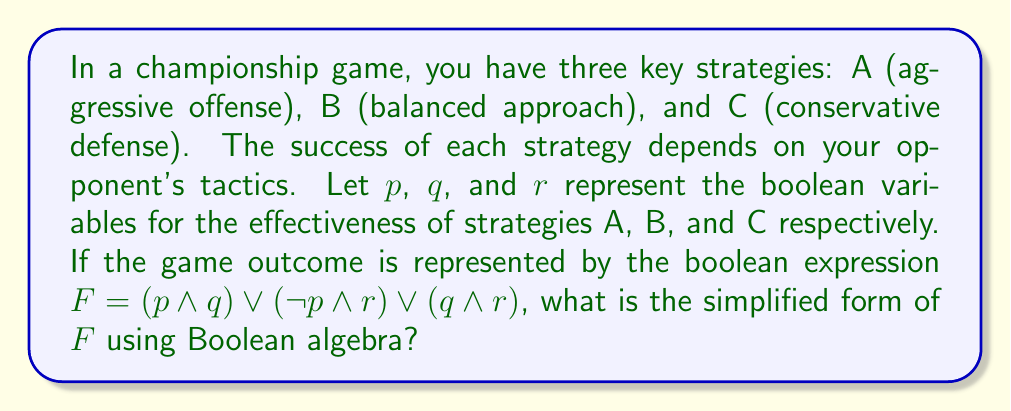Could you help me with this problem? Let's simplify the boolean expression $F = (p \land q) \lor (\neg p \land r) \lor (q \land r)$ step by step:

1) First, we can apply the distributive law to the last two terms:
   $F = (p \land q) \lor ((\neg p \lor q) \land r)$

2) Now, we can use the absorption law: $X \lor (X \land Y) = X$
   Here, $q$ is common in the first term and part of the second term:
   $F = q \lor (\neg p \land r)$

3) We can apply the distributive law again:
   $F = (q \lor \neg p) \land (q \lor r)$

4) The expression $(q \lor \neg p)$ can be simplified using one of De Morgan's laws:
   $(q \lor \neg p) = \neg(\neg q \land p)$

5) Therefore, our final simplified expression is:
   $F = \neg(\neg q \land p) \land (q \lor r)$

This simplified form represents the winning conditions based on the effectiveness of your strategies, reflecting how a Hall of Fame athlete might analyze game situations to overcome challenges and achieve victory.
Answer: $F = \neg(\neg q \land p) \land (q \lor r)$ 